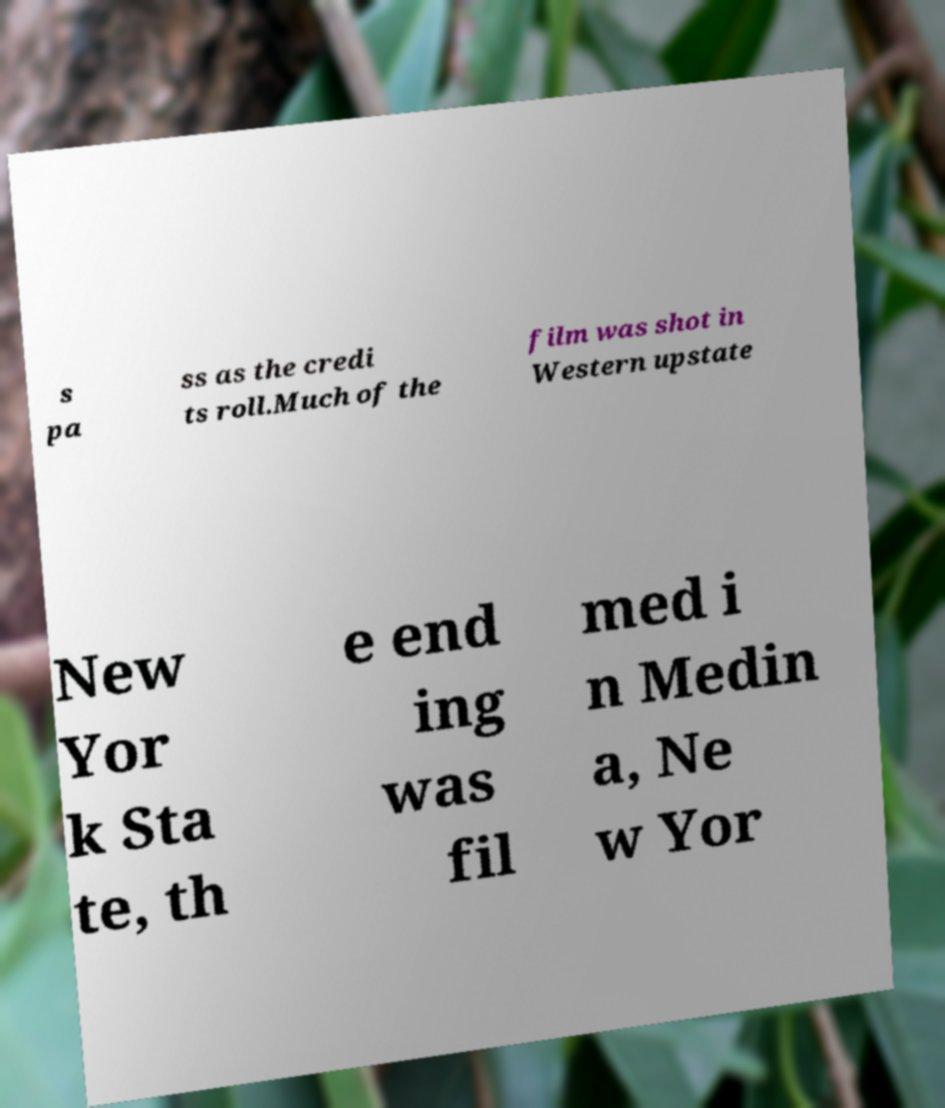Can you accurately transcribe the text from the provided image for me? s pa ss as the credi ts roll.Much of the film was shot in Western upstate New Yor k Sta te, th e end ing was fil med i n Medin a, Ne w Yor 